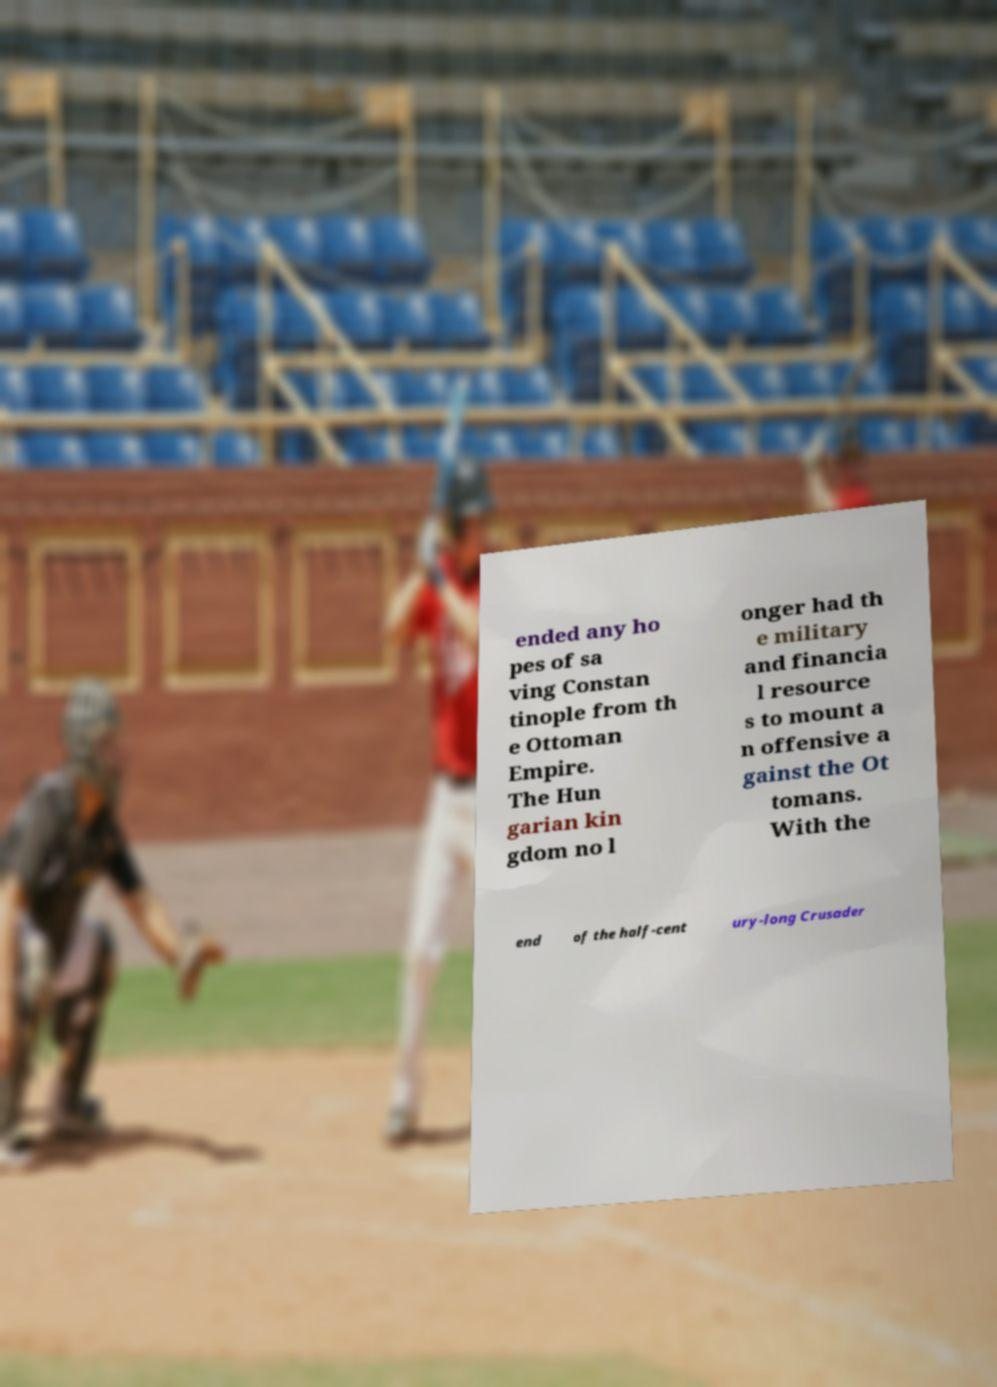Could you assist in decoding the text presented in this image and type it out clearly? ended any ho pes of sa ving Constan tinople from th e Ottoman Empire. The Hun garian kin gdom no l onger had th e military and financia l resource s to mount a n offensive a gainst the Ot tomans. With the end of the half-cent ury-long Crusader 